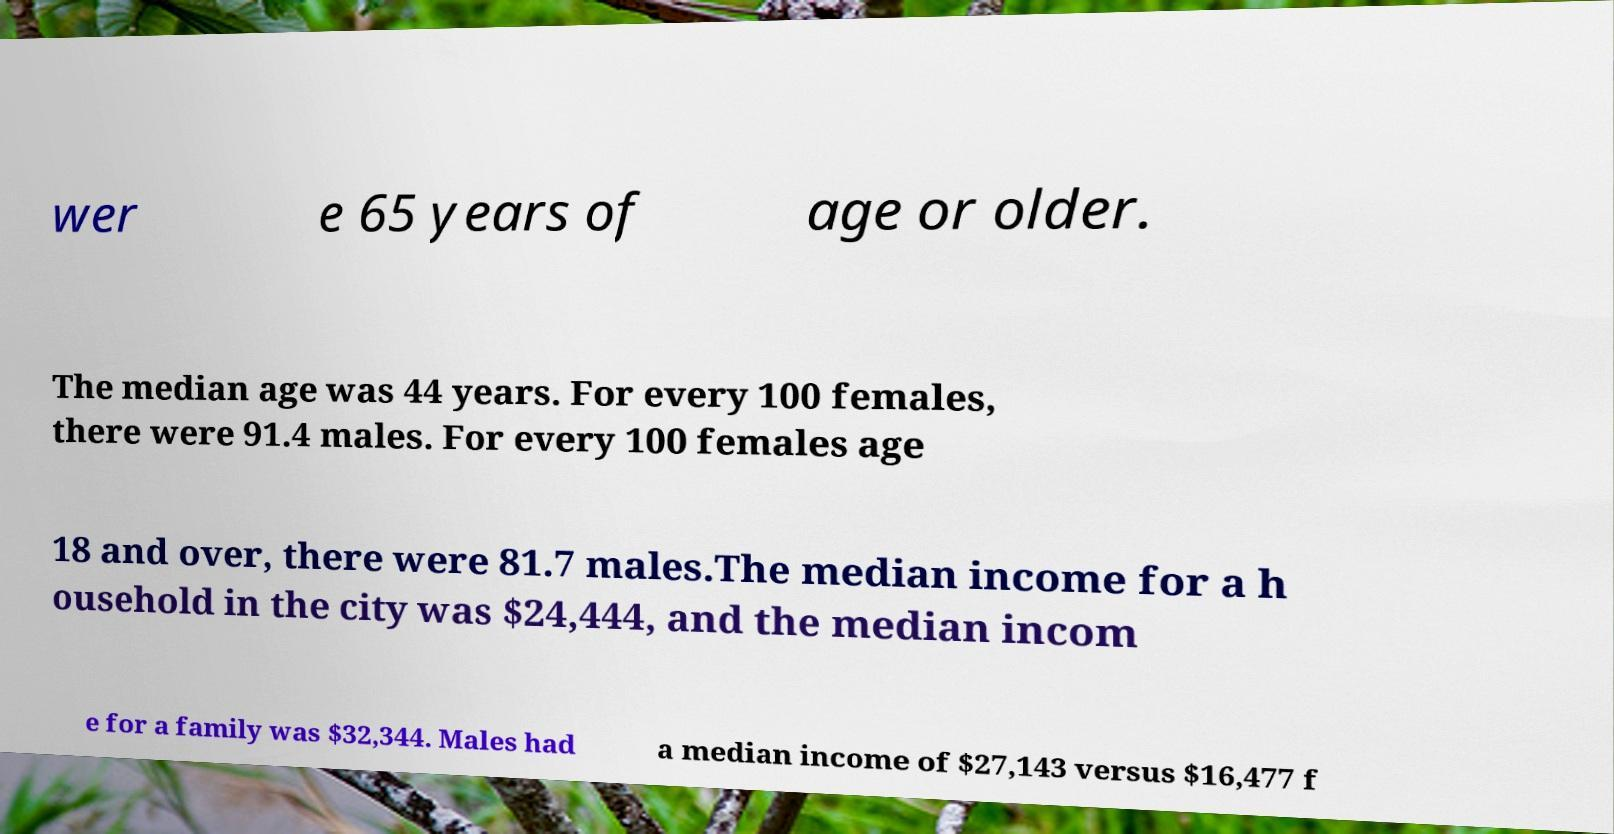Can you read and provide the text displayed in the image?This photo seems to have some interesting text. Can you extract and type it out for me? wer e 65 years of age or older. The median age was 44 years. For every 100 females, there were 91.4 males. For every 100 females age 18 and over, there were 81.7 males.The median income for a h ousehold in the city was $24,444, and the median incom e for a family was $32,344. Males had a median income of $27,143 versus $16,477 f 